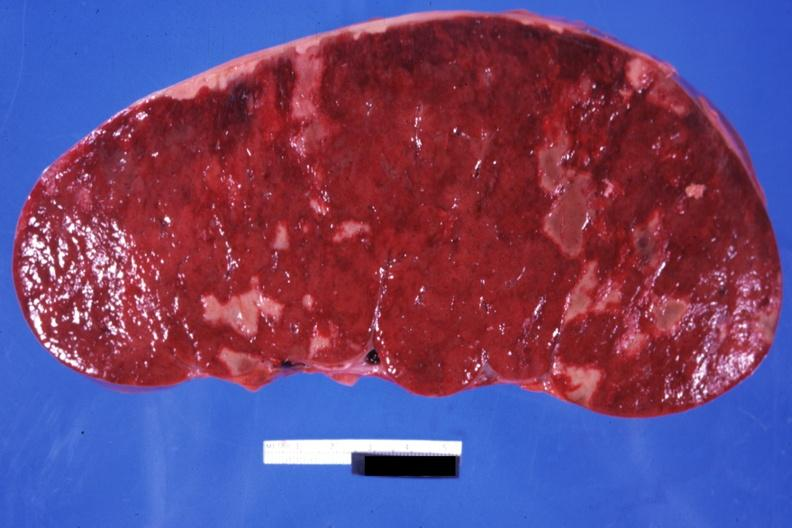what is easily seen?
Answer the question using a single word or phrase. Very enlarged spleen with multiple infarcts infiltrative process 